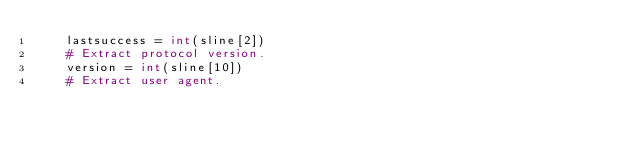<code> <loc_0><loc_0><loc_500><loc_500><_Python_>    lastsuccess = int(sline[2])
    # Extract protocol version.
    version = int(sline[10])
    # Extract user agent.</code> 